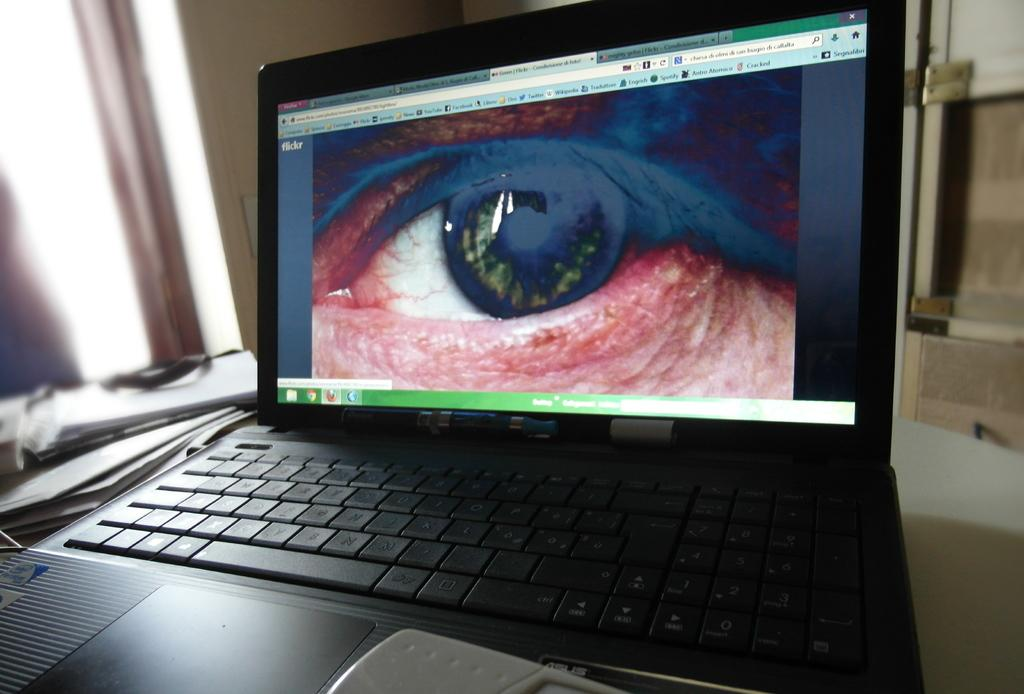What electronic device is visible in the image? There is a laptop in the image. What is displayed on the laptop screen? The laptop screen displays a picture of a human eye. What can be seen on the left side of the image? There are papers on the left side of the image. How would you describe the background of the image? The background of the image is blurry. What type of drum is being played in the image? There is no drum present in the image; it features a laptop with a picture of a human eye on its screen, papers on the left side, and a blurry background. 